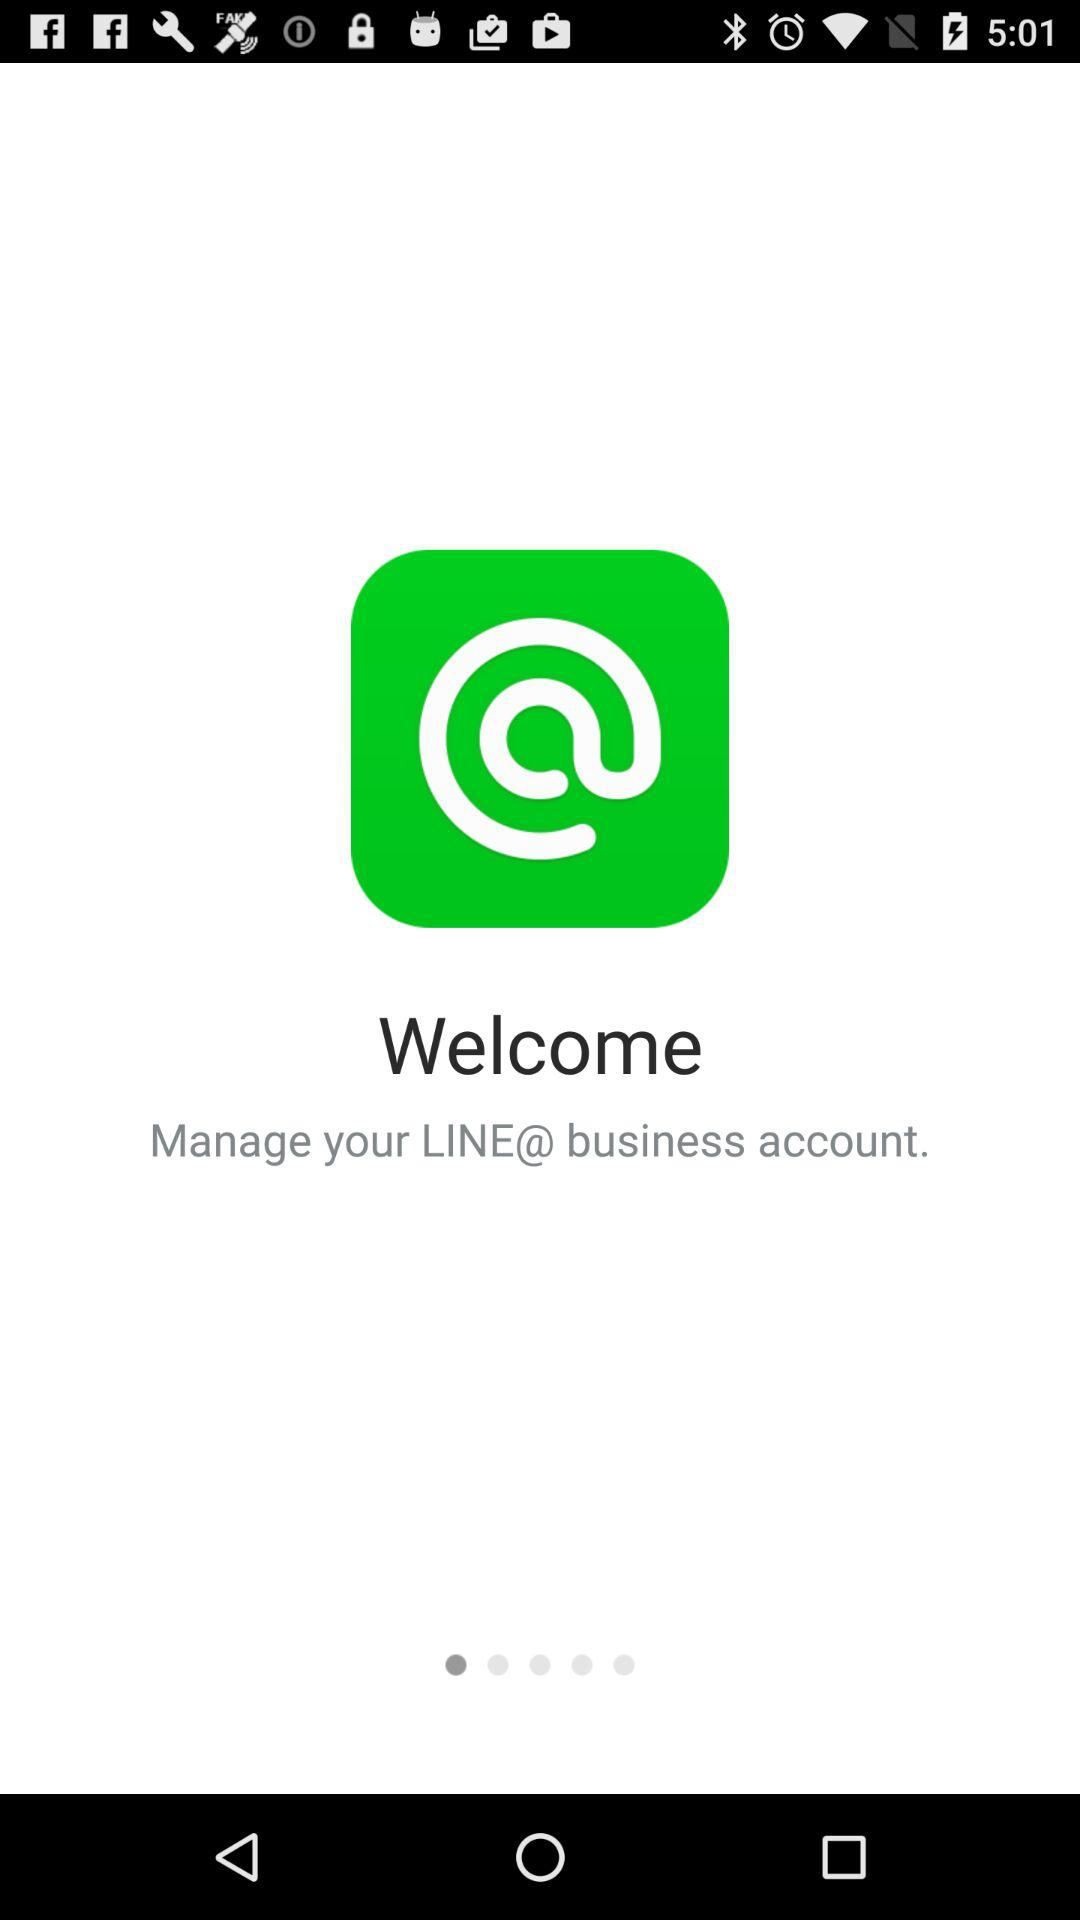What is the name of the application? The name of the application is "LINE@". 